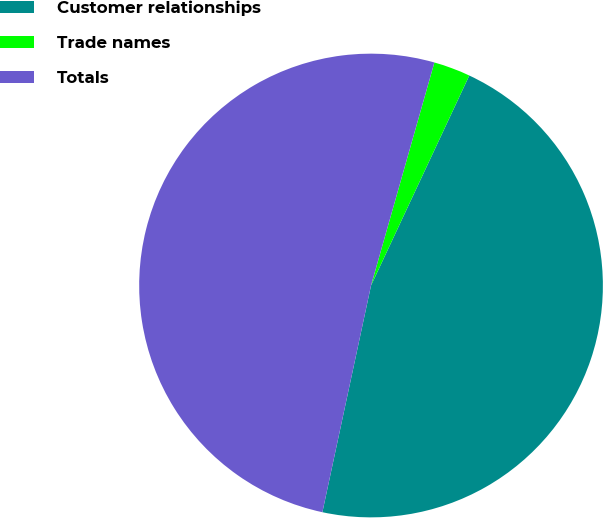Convert chart to OTSL. <chart><loc_0><loc_0><loc_500><loc_500><pie_chart><fcel>Customer relationships<fcel>Trade names<fcel>Totals<nl><fcel>46.4%<fcel>2.56%<fcel>51.04%<nl></chart> 